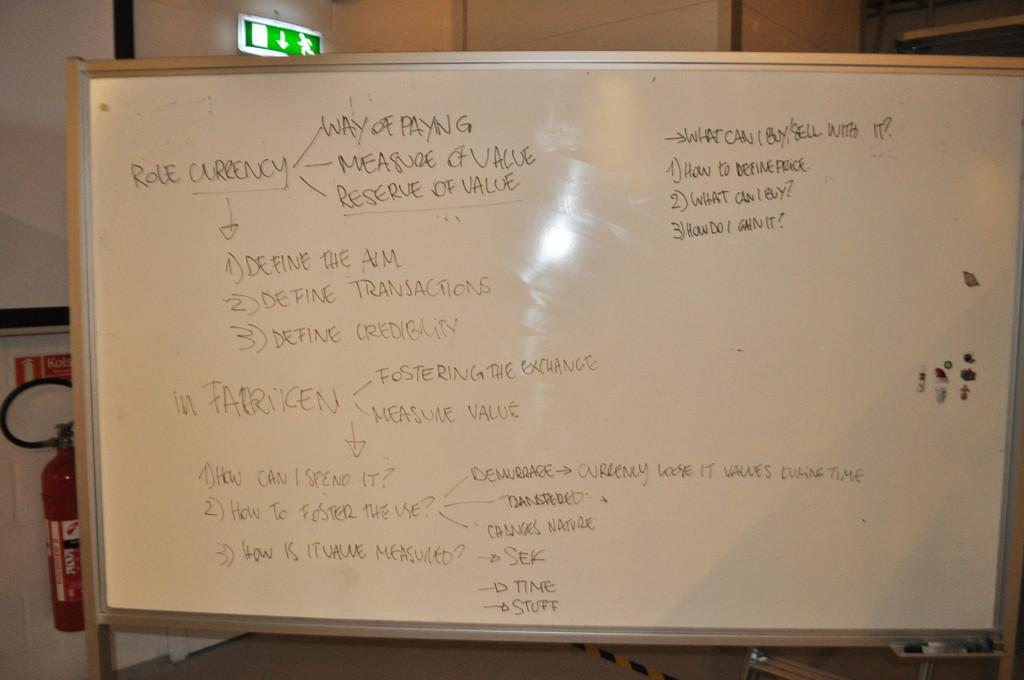Provide a one-sentence caption for the provided image. A flowchart written on a whiteboard tells of Role Currency and how to define things. 